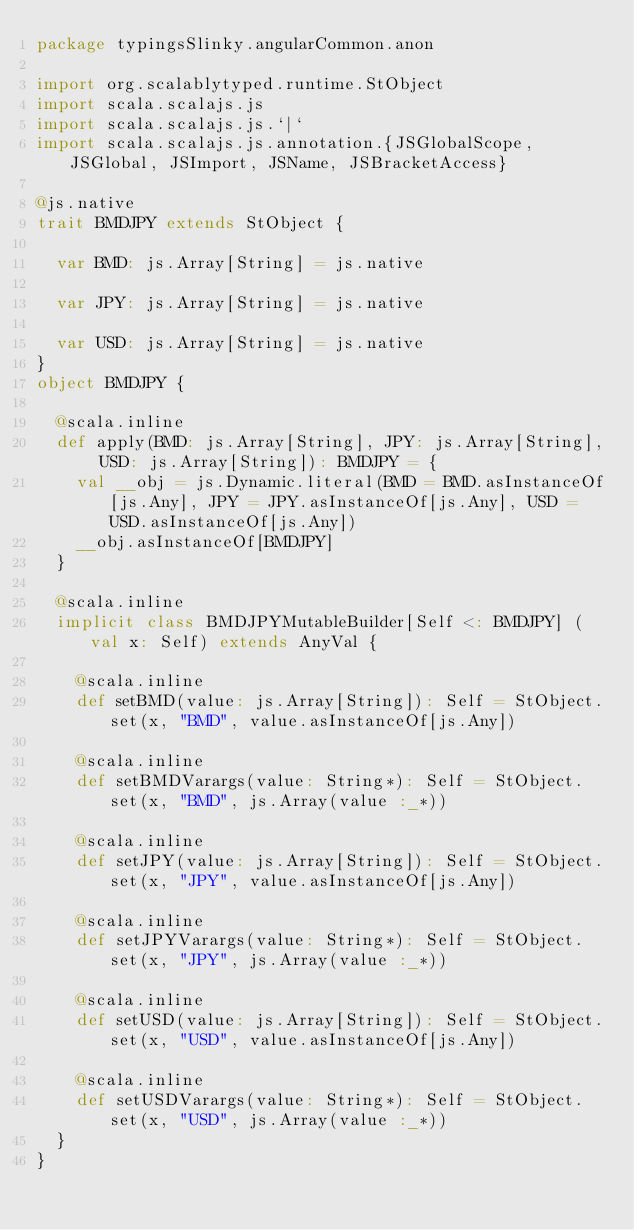<code> <loc_0><loc_0><loc_500><loc_500><_Scala_>package typingsSlinky.angularCommon.anon

import org.scalablytyped.runtime.StObject
import scala.scalajs.js
import scala.scalajs.js.`|`
import scala.scalajs.js.annotation.{JSGlobalScope, JSGlobal, JSImport, JSName, JSBracketAccess}

@js.native
trait BMDJPY extends StObject {
  
  var BMD: js.Array[String] = js.native
  
  var JPY: js.Array[String] = js.native
  
  var USD: js.Array[String] = js.native
}
object BMDJPY {
  
  @scala.inline
  def apply(BMD: js.Array[String], JPY: js.Array[String], USD: js.Array[String]): BMDJPY = {
    val __obj = js.Dynamic.literal(BMD = BMD.asInstanceOf[js.Any], JPY = JPY.asInstanceOf[js.Any], USD = USD.asInstanceOf[js.Any])
    __obj.asInstanceOf[BMDJPY]
  }
  
  @scala.inline
  implicit class BMDJPYMutableBuilder[Self <: BMDJPY] (val x: Self) extends AnyVal {
    
    @scala.inline
    def setBMD(value: js.Array[String]): Self = StObject.set(x, "BMD", value.asInstanceOf[js.Any])
    
    @scala.inline
    def setBMDVarargs(value: String*): Self = StObject.set(x, "BMD", js.Array(value :_*))
    
    @scala.inline
    def setJPY(value: js.Array[String]): Self = StObject.set(x, "JPY", value.asInstanceOf[js.Any])
    
    @scala.inline
    def setJPYVarargs(value: String*): Self = StObject.set(x, "JPY", js.Array(value :_*))
    
    @scala.inline
    def setUSD(value: js.Array[String]): Self = StObject.set(x, "USD", value.asInstanceOf[js.Any])
    
    @scala.inline
    def setUSDVarargs(value: String*): Self = StObject.set(x, "USD", js.Array(value :_*))
  }
}
</code> 